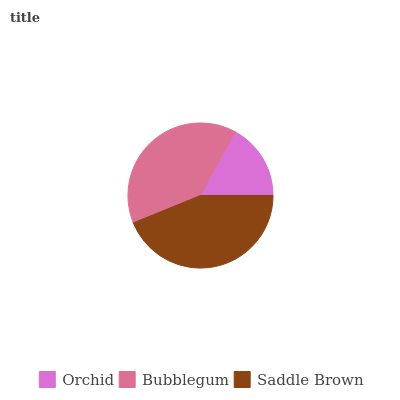Is Orchid the minimum?
Answer yes or no. Yes. Is Saddle Brown the maximum?
Answer yes or no. Yes. Is Bubblegum the minimum?
Answer yes or no. No. Is Bubblegum the maximum?
Answer yes or no. No. Is Bubblegum greater than Orchid?
Answer yes or no. Yes. Is Orchid less than Bubblegum?
Answer yes or no. Yes. Is Orchid greater than Bubblegum?
Answer yes or no. No. Is Bubblegum less than Orchid?
Answer yes or no. No. Is Bubblegum the high median?
Answer yes or no. Yes. Is Bubblegum the low median?
Answer yes or no. Yes. Is Orchid the high median?
Answer yes or no. No. Is Saddle Brown the low median?
Answer yes or no. No. 